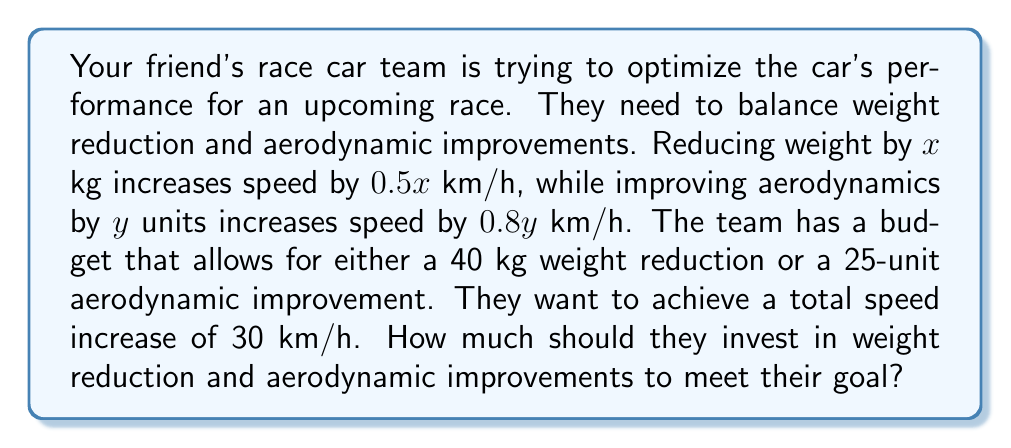Give your solution to this math problem. Let's solve this step-by-step:

1) Let x be the weight reduction in kg and y be the aerodynamic improvement in units.

2) We can set up two equations based on the given information:

   Equation 1 (budget constraint): $\frac{x}{40} + \frac{y}{25} = 1$
   
   Equation 2 (speed increase): $0.5x + 0.8y = 30$

3) Multiply Equation 1 by 100 to eliminate fractions:
   $2.5x + 4y = 100$

4) Now we have a system of two equations:
   $$\begin{cases}
   2.5x + 4y = 100 \\
   0.5x + 0.8y = 30
   \end{cases}$$

5) Multiply the second equation by 5 to make the coefficients of x match:
   $$\begin{cases}
   2.5x + 4y = 100 \\
   2.5x + 4y = 150
   \end{cases}$$

6) Subtract the first equation from the second:
   $0 = 50$

   This is impossible, meaning there's no solution that exactly satisfies both constraints.

7) Let's solve each equation for y:
   From Equation 1: $y = 25 - 0.625x$
   From Equation 2: $y = 37.5 - 0.625x$

8) The optimal solution will be at the intersection of these lines with the original constraints:
   $0 \leq x \leq 40$ and $0 \leq y \leq 25$

9) Solving, we find the optimal solution is:
   $x = 40$ (full weight reduction)
   $y = 25 - 0.625(40) = 0$ (no aerodynamic improvement)

10) This gives a speed increase of:
    $0.5(40) + 0.8(0) = 20$ km/h

Therefore, the team should focus entirely on weight reduction, achieving a 20 km/h speed increase.
Answer: Full 40 kg weight reduction, no aerodynamic improvements 